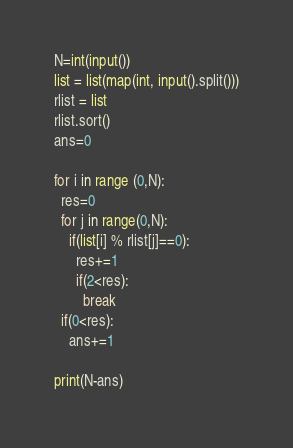Convert code to text. <code><loc_0><loc_0><loc_500><loc_500><_Python_>N=int(input())
list = list(map(int, input().split()))
rlist = list
rlist.sort()
ans=0

for i in range (0,N):
  res=0
  for j in range(0,N):
    if(list[i] % rlist[j]==0):
      res+=1
      if(2<res):
        break
  if(0<res):
    ans+=1

print(N-ans)</code> 